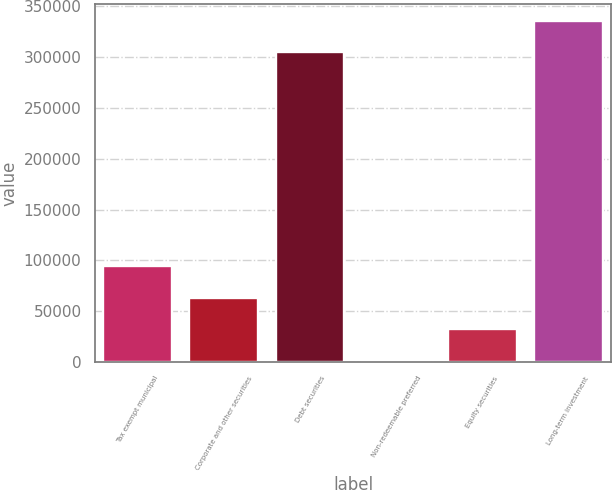Convert chart to OTSL. <chart><loc_0><loc_0><loc_500><loc_500><bar_chart><fcel>Tax exempt municipal<fcel>Corporate and other securities<fcel>Debt securities<fcel>Non-redeemable preferred<fcel>Equity securities<fcel>Long-term investment<nl><fcel>94099.3<fcel>63477.2<fcel>304821<fcel>2233<fcel>32855.1<fcel>335443<nl></chart> 